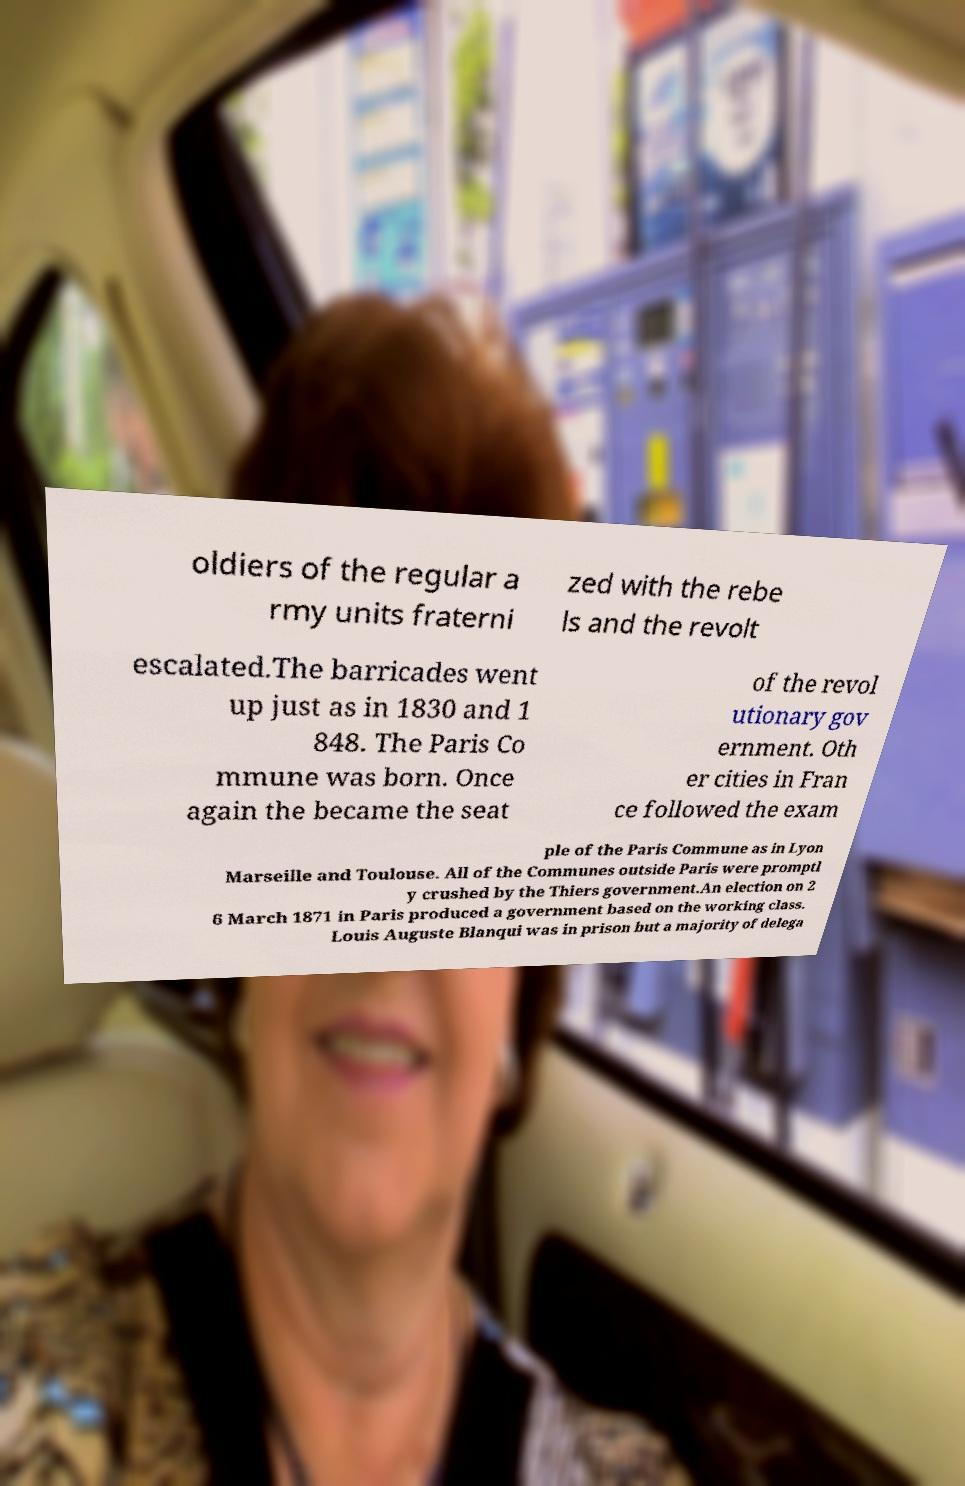I need the written content from this picture converted into text. Can you do that? oldiers of the regular a rmy units fraterni zed with the rebe ls and the revolt escalated.The barricades went up just as in 1830 and 1 848. The Paris Co mmune was born. Once again the became the seat of the revol utionary gov ernment. Oth er cities in Fran ce followed the exam ple of the Paris Commune as in Lyon Marseille and Toulouse. All of the Communes outside Paris were promptl y crushed by the Thiers government.An election on 2 6 March 1871 in Paris produced a government based on the working class. Louis Auguste Blanqui was in prison but a majority of delega 